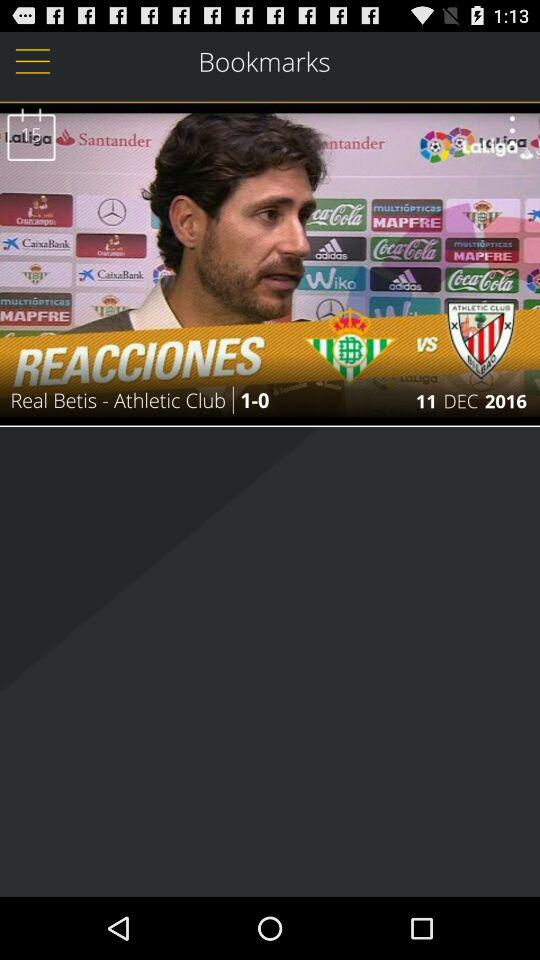In what month was the match played? The match was played in December. 